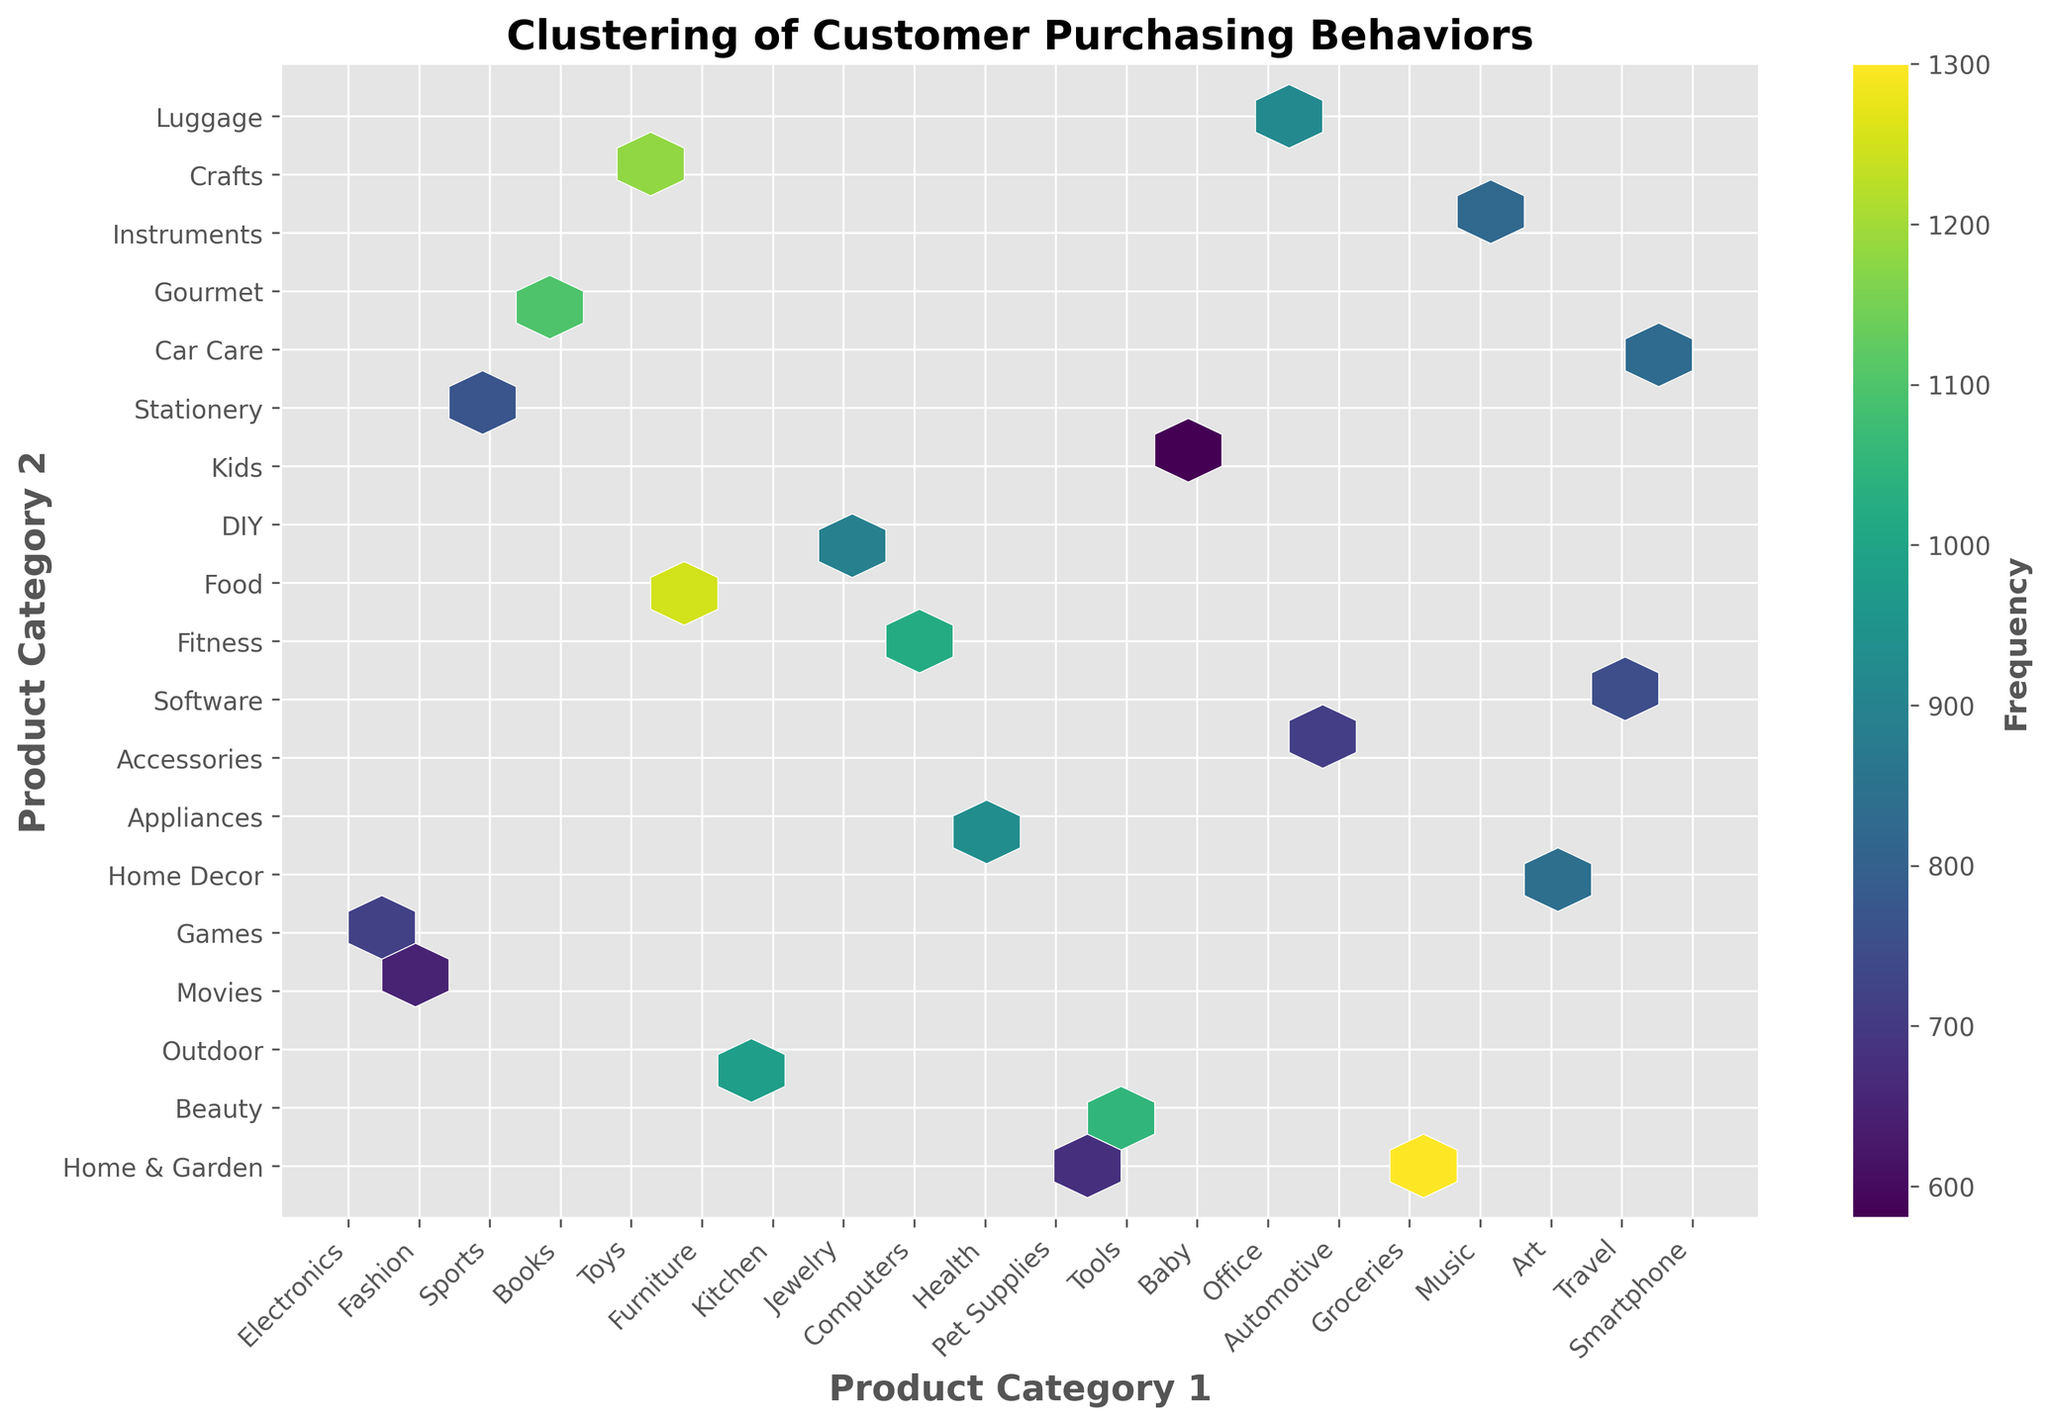What is the title of the figure? The title is usually found at the top of the figure and describes what the plot is representing.
Answer: Clustering of Customer Purchasing Behaviors What are the labels on the x-axis and y-axis? The x-axis and y-axis labels typically indicate what the axes represent.
Answer: Product Category 1 and Product Category 2 Which product combination has the highest frequency? Look for the hexbin with the highest intensity color, which represents the highest frequency. Use the color bar as a reference.
Answer: Smartphone, Accessories What is the frequency of the combination of "Electronics" and "Home & Garden"? Locate the hexbin representing this combination and refer to its color intensity, which indicates its frequency.
Answer: 1250 How many unique product categories are there on the x-axis? Count the number of unique labels along the x-axis.
Answer: 19 On average, what is the frequency of the displayed product combinations? Sum all frequency values and divide by the number of combinations. (1250 + 980 + 820 + 1100 + 750 + 890 + 1050 + 680 + 1180 + 930 + 710 + 840 + 770 + 920 + 650 + 1020 + 580 + 720 + 830 + 1300) / 20 = 943
Answer: 943 Compare the frequency of "Books, Movies" with "Computers, Software". Which one is higher, and by how much? Find the frequencies for each combination and calculate the difference. Books and Movies have 1100; Computers and Software have 1180. So, 1180 - 1100 = 80.
Answer: Computers, Software by 80 Which product combination has the lowest frequency? Identify the hexbin with the lowest color intensity, referring to the color bar for comparison.
Answer: Music, Instruments Are there any product combinations with the same frequency? If so, which ones? Look for hexbins with the same color intensity and confirm via the color bar.
Answer: No combinations have the same frequency What can the color gradient in the hexbin plot tell us about the customer purchasing behaviors on e-commerce platforms? The color gradient represents the frequency of each product combination being purchased together. Higher intensity (darker) colors indicate more frequent combinations, while lower intensity (lighter) colors indicate less frequent combinations, showing popular trends in customer behavior.
Answer: Indicate popular and less popular combinations 